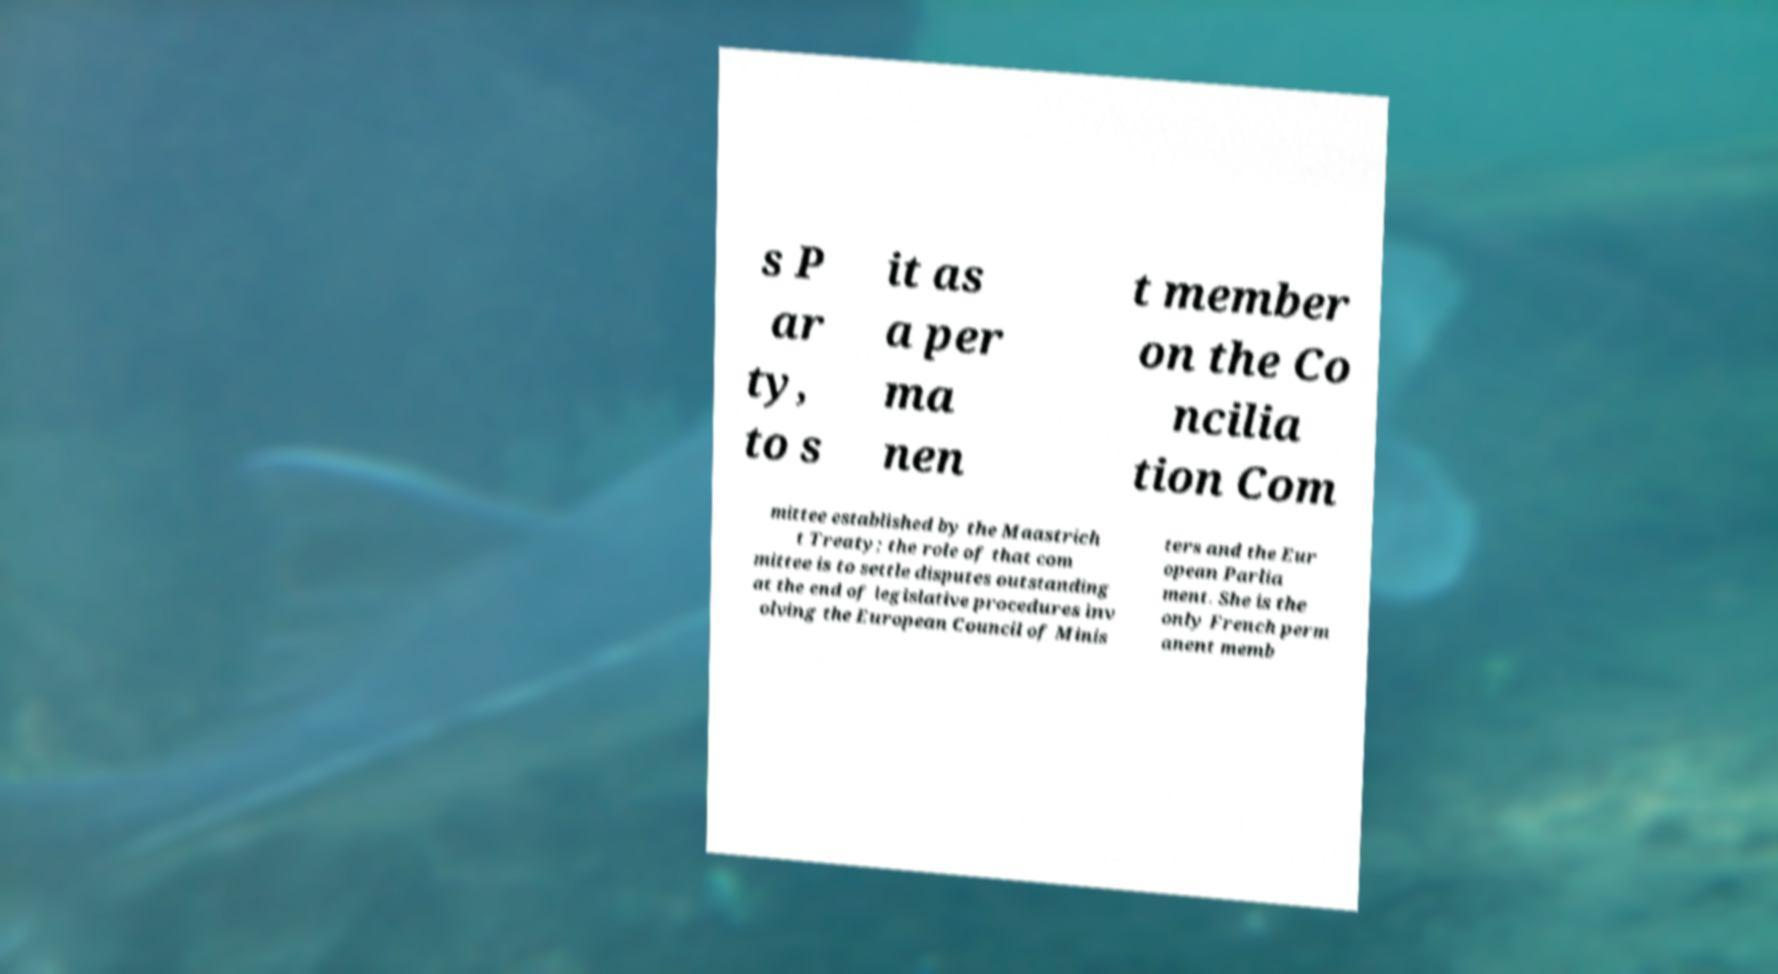Could you extract and type out the text from this image? s P ar ty, to s it as a per ma nen t member on the Co ncilia tion Com mittee established by the Maastrich t Treaty; the role of that com mittee is to settle disputes outstanding at the end of legislative procedures inv olving the European Council of Minis ters and the Eur opean Parlia ment. She is the only French perm anent memb 